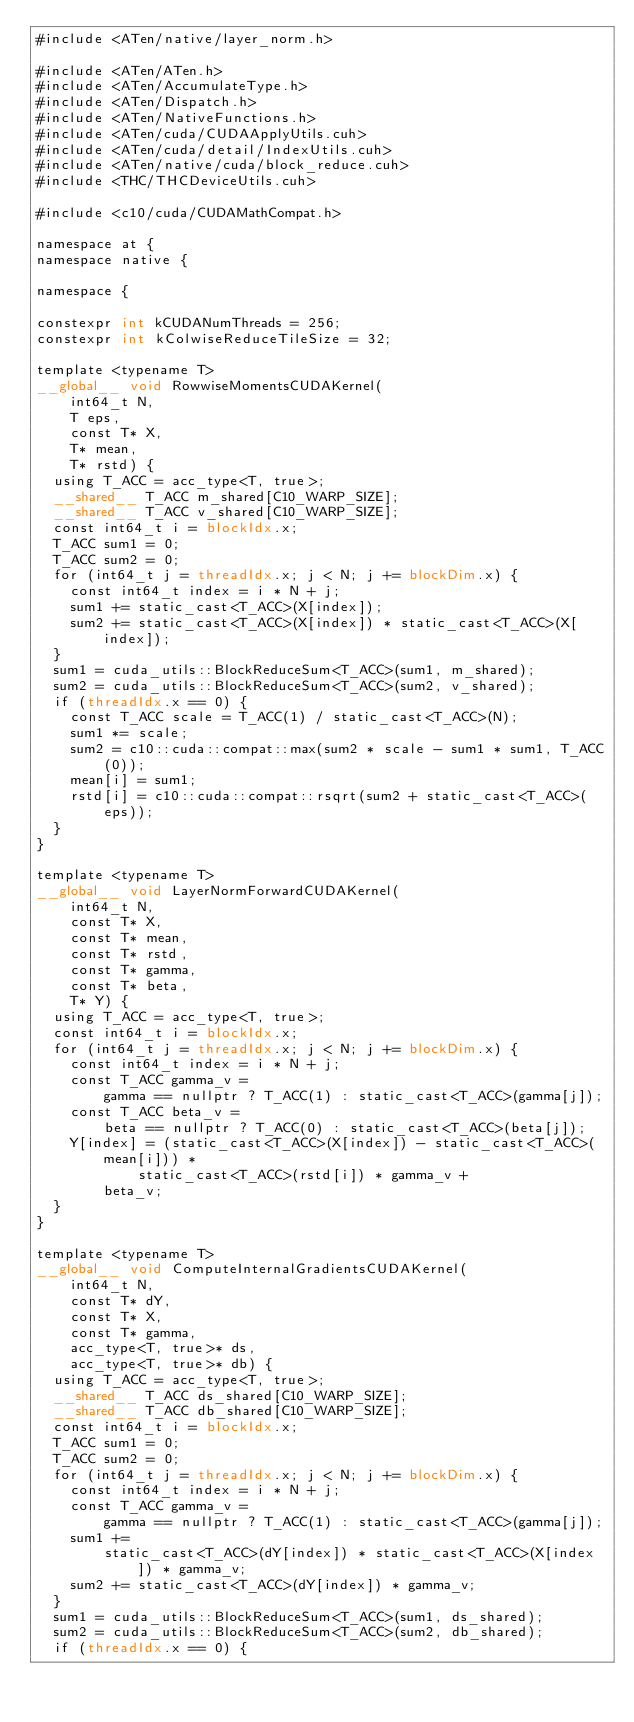Convert code to text. <code><loc_0><loc_0><loc_500><loc_500><_Cuda_>#include <ATen/native/layer_norm.h>

#include <ATen/ATen.h>
#include <ATen/AccumulateType.h>
#include <ATen/Dispatch.h>
#include <ATen/NativeFunctions.h>
#include <ATen/cuda/CUDAApplyUtils.cuh>
#include <ATen/cuda/detail/IndexUtils.cuh>
#include <ATen/native/cuda/block_reduce.cuh>
#include <THC/THCDeviceUtils.cuh>

#include <c10/cuda/CUDAMathCompat.h>

namespace at {
namespace native {

namespace {

constexpr int kCUDANumThreads = 256;
constexpr int kColwiseReduceTileSize = 32;

template <typename T>
__global__ void RowwiseMomentsCUDAKernel(
    int64_t N,
    T eps,
    const T* X,
    T* mean,
    T* rstd) {
  using T_ACC = acc_type<T, true>;
  __shared__ T_ACC m_shared[C10_WARP_SIZE];
  __shared__ T_ACC v_shared[C10_WARP_SIZE];
  const int64_t i = blockIdx.x;
  T_ACC sum1 = 0;
  T_ACC sum2 = 0;
  for (int64_t j = threadIdx.x; j < N; j += blockDim.x) {
    const int64_t index = i * N + j;
    sum1 += static_cast<T_ACC>(X[index]);
    sum2 += static_cast<T_ACC>(X[index]) * static_cast<T_ACC>(X[index]);
  }
  sum1 = cuda_utils::BlockReduceSum<T_ACC>(sum1, m_shared);
  sum2 = cuda_utils::BlockReduceSum<T_ACC>(sum2, v_shared);
  if (threadIdx.x == 0) {
    const T_ACC scale = T_ACC(1) / static_cast<T_ACC>(N);
    sum1 *= scale;
    sum2 = c10::cuda::compat::max(sum2 * scale - sum1 * sum1, T_ACC(0));
    mean[i] = sum1;
    rstd[i] = c10::cuda::compat::rsqrt(sum2 + static_cast<T_ACC>(eps));
  }
}

template <typename T>
__global__ void LayerNormForwardCUDAKernel(
    int64_t N,
    const T* X,
    const T* mean,
    const T* rstd,
    const T* gamma,
    const T* beta,
    T* Y) {
  using T_ACC = acc_type<T, true>;
  const int64_t i = blockIdx.x;
  for (int64_t j = threadIdx.x; j < N; j += blockDim.x) {
    const int64_t index = i * N + j;
    const T_ACC gamma_v =
        gamma == nullptr ? T_ACC(1) : static_cast<T_ACC>(gamma[j]);
    const T_ACC beta_v =
        beta == nullptr ? T_ACC(0) : static_cast<T_ACC>(beta[j]);
    Y[index] = (static_cast<T_ACC>(X[index]) - static_cast<T_ACC>(mean[i])) *
            static_cast<T_ACC>(rstd[i]) * gamma_v +
        beta_v;
  }
}

template <typename T>
__global__ void ComputeInternalGradientsCUDAKernel(
    int64_t N,
    const T* dY,
    const T* X,
    const T* gamma,
    acc_type<T, true>* ds,
    acc_type<T, true>* db) {
  using T_ACC = acc_type<T, true>;
  __shared__ T_ACC ds_shared[C10_WARP_SIZE];
  __shared__ T_ACC db_shared[C10_WARP_SIZE];
  const int64_t i = blockIdx.x;
  T_ACC sum1 = 0;
  T_ACC sum2 = 0;
  for (int64_t j = threadIdx.x; j < N; j += blockDim.x) {
    const int64_t index = i * N + j;
    const T_ACC gamma_v =
        gamma == nullptr ? T_ACC(1) : static_cast<T_ACC>(gamma[j]);
    sum1 +=
        static_cast<T_ACC>(dY[index]) * static_cast<T_ACC>(X[index]) * gamma_v;
    sum2 += static_cast<T_ACC>(dY[index]) * gamma_v;
  }
  sum1 = cuda_utils::BlockReduceSum<T_ACC>(sum1, ds_shared);
  sum2 = cuda_utils::BlockReduceSum<T_ACC>(sum2, db_shared);
  if (threadIdx.x == 0) {</code> 